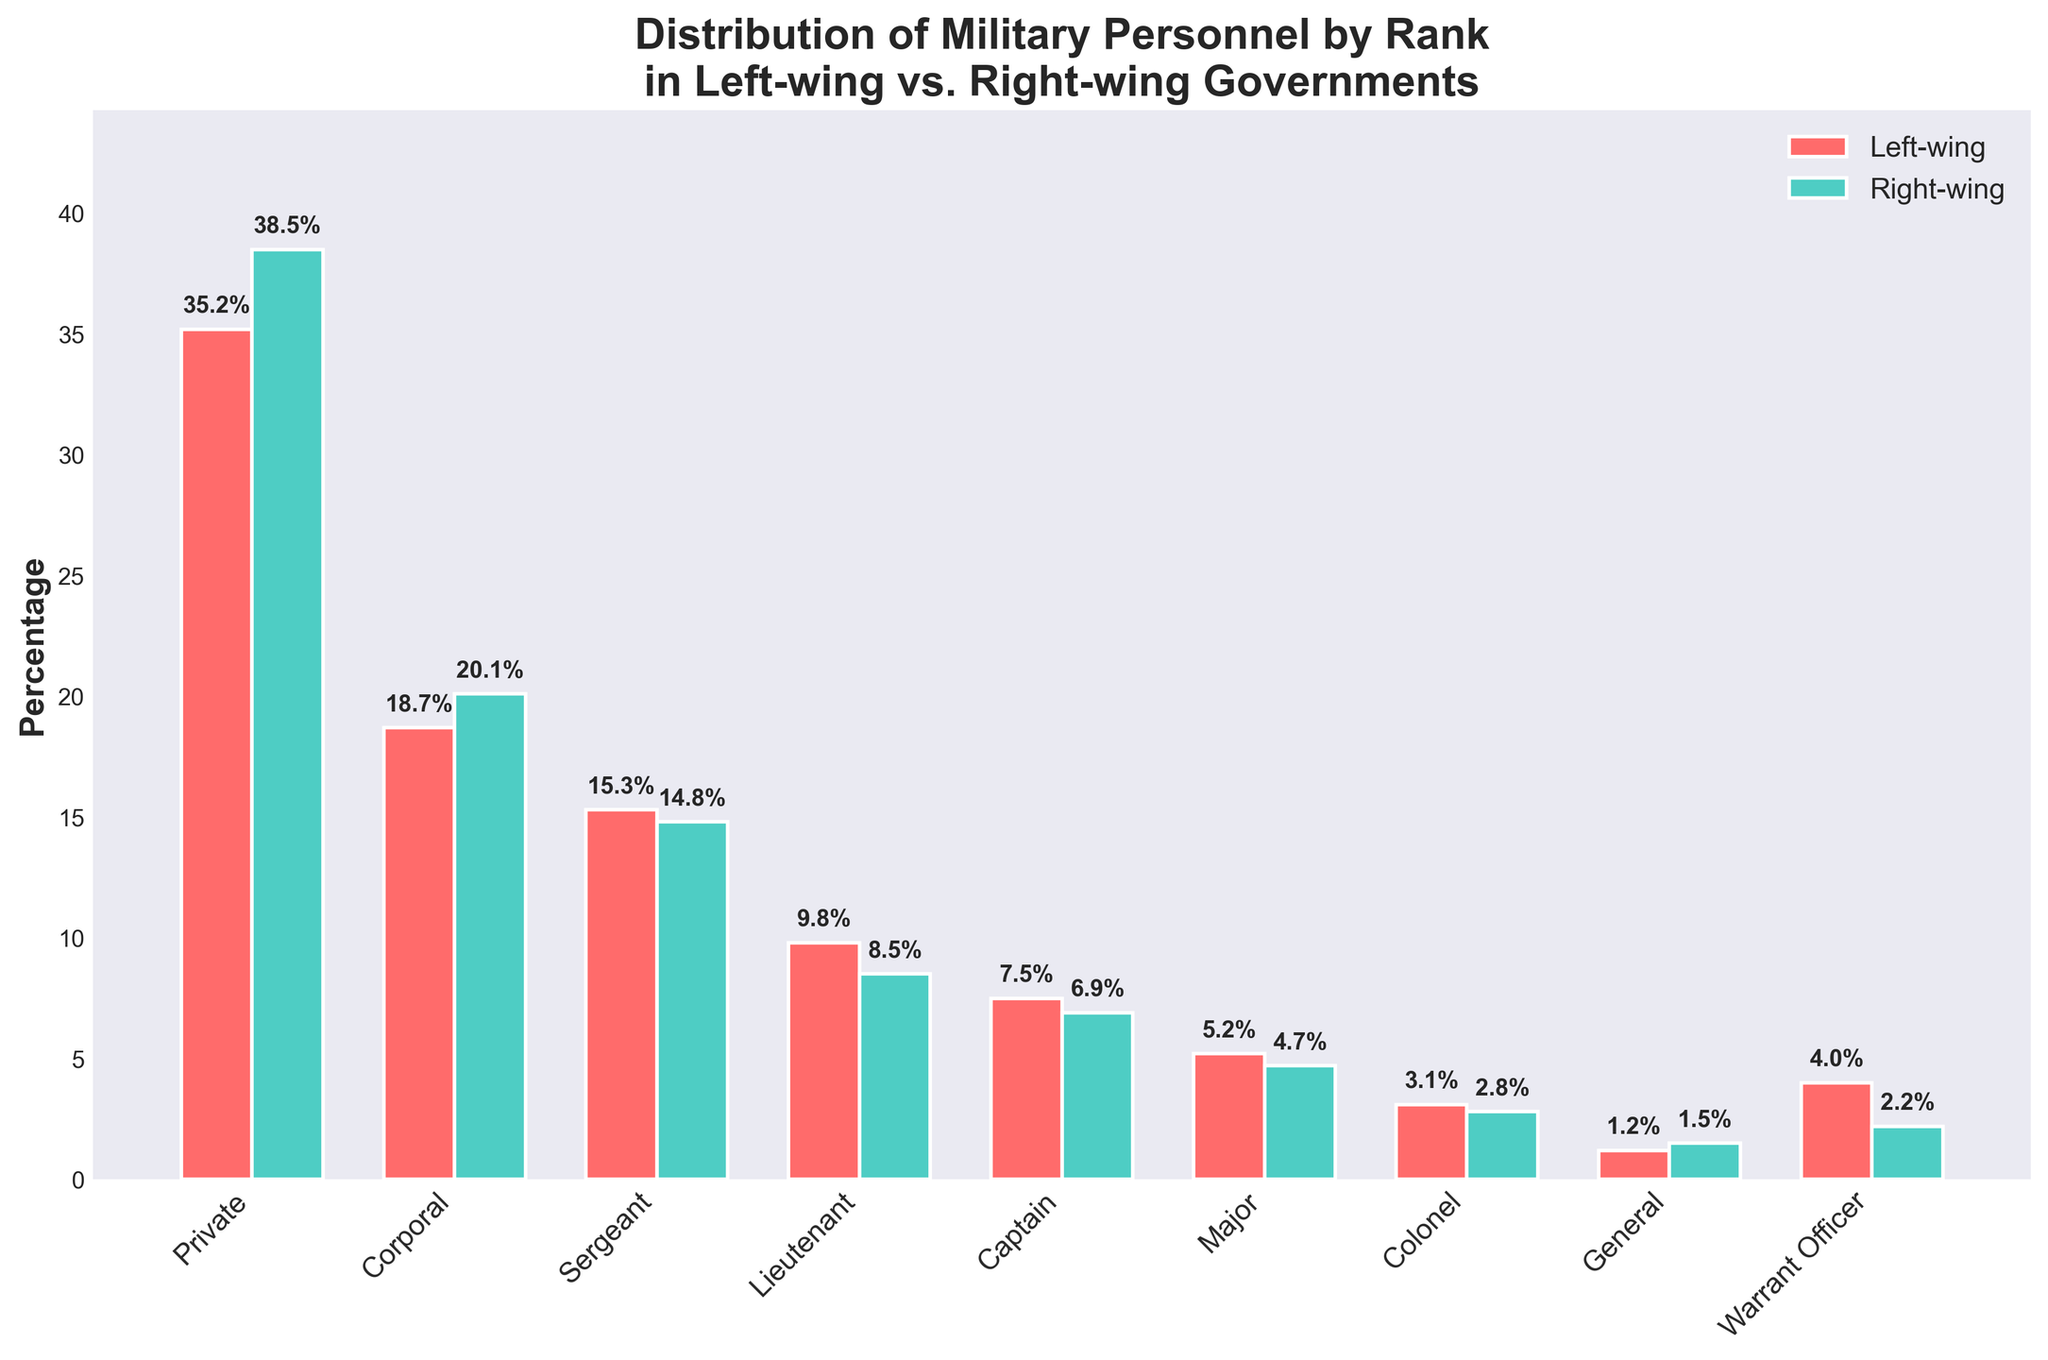Which rank has the highest percentage of personnel in right-wing governments? From the figure, look at the heights of the bars representing 'Right-wing'. The highest bar represents the rank with the highest percentage.
Answer: Private What is the difference in percentage of Corporals between left-wing and right-wing governments? Identify the bars for 'Corporal' in both groups and subtract the 'Left-wing' percentage from the 'Right-wing' percentage: 20.1% - 18.7%
Answer: 1.4% Which rank shows the greatest disparity in percentage between left-wing and right-wing governments? Calculate the absolute difference in percentages for each rank between 'Left-wing' and 'Right-wing' and identify the rank with the largest difference. 'Warrant Officer' has the highest difference: 4.0% - 2.2% = 1.8%
Answer: Warrant Officer Are there more Generals in left-wing or right-wing governments? Compare the heights of the bars representing 'General' for both groups. The bar for 'Right-wing' is slightly taller.
Answer: Right-wing What is the combined percentage of Majors and Colonels in left-wing governments? Add the percentages for 'Major' and 'Colonel' in the 'Left-wing' group: 5.2% + 3.1%
Answer: 8.3% Which group has a higher percentage of personnel at the Lieutenant rank? Compare the heights of the bars for 'Lieutenant' across both groups. The 'Left-wing' bar is taller than the 'Right-wing' bar.
Answer: Left-wing Is the percentage of Sergeants higher in left-wing or right-wing governments? Compare the bars for 'Sergeant'. The 'Left-wing' bar is slightly higher than the 'Right-wing' bar.
Answer: Left-wing What is the average percentage of Privates and Corporals in right-wing governments? Add the percentages for 'Private' and 'Corporal' in the 'Right-wing' group and divide by 2: (38.5% + 20.1%) / 2
Answer: 29.3% How much higher is the percentage of Warrant Officers in left-wing governments compared to right-wing governments? Find the difference in percentage for 'Warrant Officer' between 'Left-wing' and 'Right-wing': 4.0% - 2.2%
Answer: 1.8% Which rank has a nearly identical percentage in both left-wing and right-wing governments? Compare the bars and find the rank where the heights are nearly the same. The rank 'General' has similar percentages: 1.2% (Left-wing) and 1.5% (Right-wing).
Answer: General 